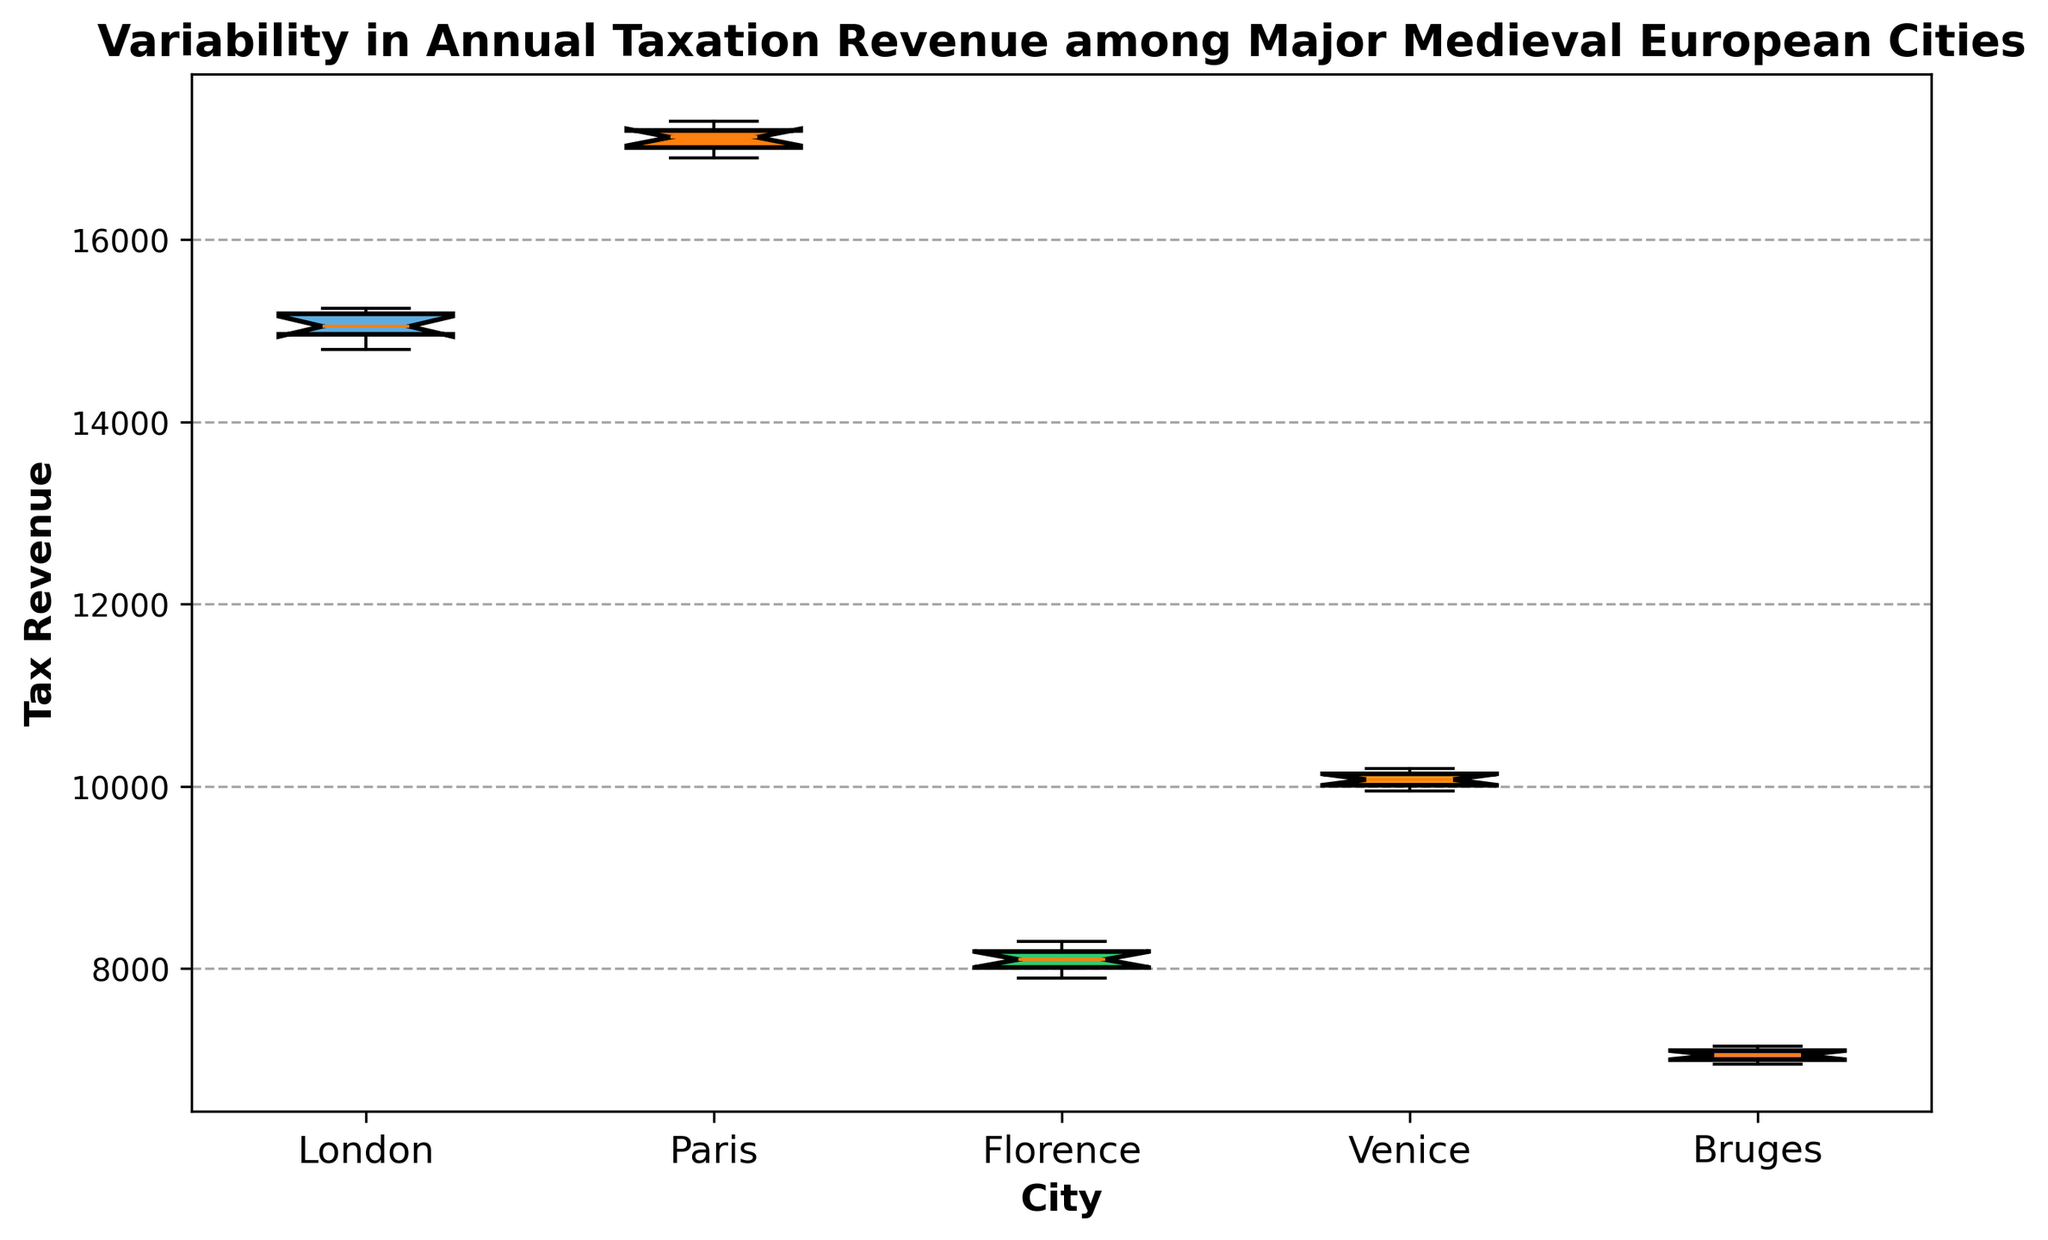What city has the highest median tax revenue? The middle value of the tax revenues when arranged in ascending order is the median. From the box plot, Paris has the highest central line within the box, indicating the highest median tax revenue.
Answer: Paris Which city has the least spread in tax revenue? The city with the smallest interquartile range (IQR), represented by the height of the box, indicates the least spread. Florence's box is the smallest, showing the least variability in tax revenue.
Answer: Florence Compare the median tax revenues of London and Venice. Which is higher? The median is shown by the central line of each box. London's median line is above Venice's median line, indicating that London's median tax revenue is higher than Venice's.
Answer: London How does the upper quartile (top of the box) of Bruges compare to the lower quartile (bottom of the box) of Paris? The top of Bruges' box represents its 75th percentile, and the bottom of Paris' box represents its 25th percentile. From the box plot, the upper quartile of Bruges appears lower than the lower quartile of Paris.
Answer: Bruges' upper quartile is lower Which city has the highest variability in tax revenue? The city with the largest interquartile range (IQR), shown by the tallest box, has the highest variability. Paris's box is the tallest, indicating the greatest variability in tax revenue.
Answer: Paris Which city has the lowest maximum tax revenue? The maximum tax revenue is represented by the top whisker of each box plot. The whisker extending the least upward belongs to Bruges, indicating the lowest maximum tax revenue.
Answer: Bruges Are there any outliers in the tax revenue data for these cities? Outliers are represented by individual dots outside the whiskers in a box plot. There are no dots outside the whiskers in any of the city box plots, indicating no outliers in this dataset.
Answer: No Calculate the interquartile range (IQR) for London. The IQR is the difference between the upper quartile (75th percentile) and lower quartile (25th percentile). From the plot, London's quartiles span from roughly 14950 to 15150. So, IQR = 15150 - 14950 = 200.
Answer: 200 Which city has a higher median tax revenue: Florence or Venice? The median value is shown by the central line in each box. The central line in Venice's box is higher than that in Florence's box, indicating a higher median tax revenue.
Answer: Venice 